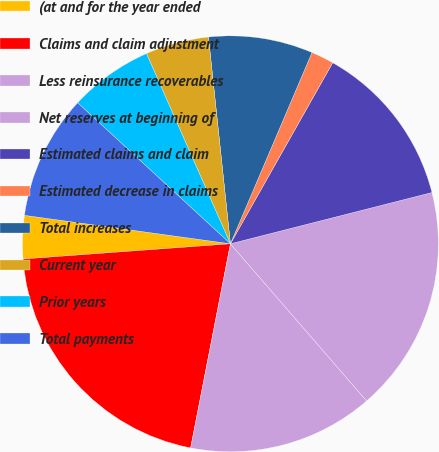Convert chart. <chart><loc_0><loc_0><loc_500><loc_500><pie_chart><fcel>(at and for the year ended<fcel>Claims and claim adjustment<fcel>Less reinsurance recoverables<fcel>Net reserves at beginning of<fcel>Estimated claims and claim<fcel>Estimated decrease in claims<fcel>Total increases<fcel>Current year<fcel>Prior years<fcel>Total payments<nl><fcel>3.35%<fcel>20.77%<fcel>14.43%<fcel>17.6%<fcel>12.85%<fcel>1.77%<fcel>8.1%<fcel>4.93%<fcel>6.52%<fcel>9.68%<nl></chart> 